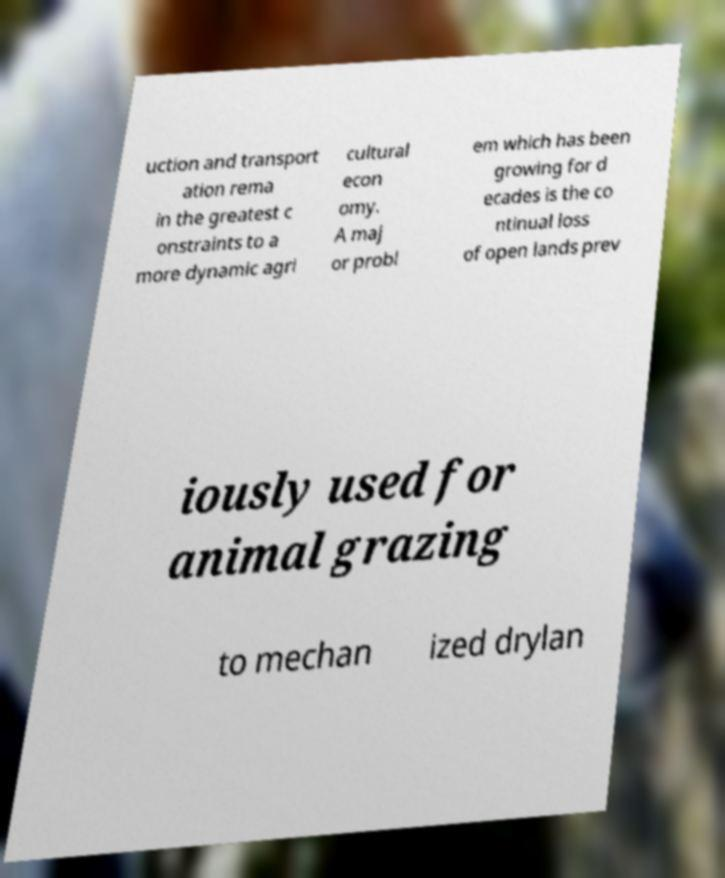Please identify and transcribe the text found in this image. uction and transport ation rema in the greatest c onstraints to a more dynamic agri cultural econ omy. A maj or probl em which has been growing for d ecades is the co ntinual loss of open lands prev iously used for animal grazing to mechan ized drylan 